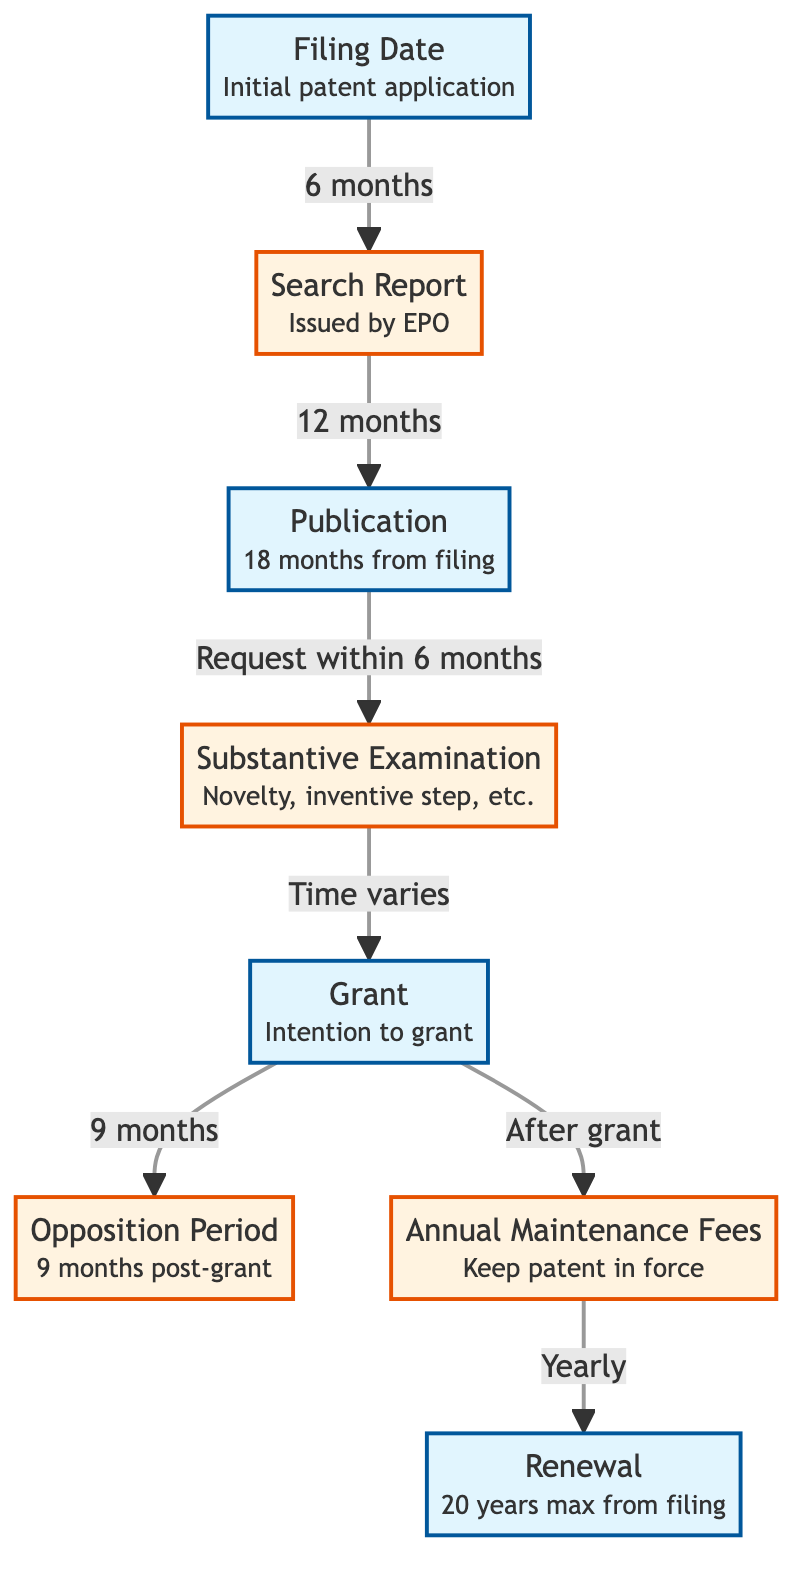What is the first milestone in the timeline? The diagram clearly indicates that the first milestone is the "Filing Date" of the initial patent application. This is the starting point from which all subsequent events are measured.
Answer: Filing Date How long after the filing date is the Search Report issued? Following the "Filing Date," the diagram states that the Search Report is issued after "6 months." This is directly indicated in the relationship between these two nodes.
Answer: 6 months What event occurs 18 months after the filing date? The diagram specifies that the "Publication" of the patent application occurs "18 months from filing." This timeline is clearly indicated between the Filing Date and Publication nodes.
Answer: Publication What is required within 6 months after publication to proceed to substantive examination? The arrow connecting the "Publication" and "Substantive Examination" nodes indicates that a "Request within 6 months" is necessary to initiate the substantive examination process. This is a critical next step in the timeline.
Answer: Request within 6 months How long is the opposition period after the grant? According to the diagram, the "Opposition Period" is specified as "9 months post-grant." This is indicated directly below the Grant milestone, showing the time frame allowed for opposition.
Answer: 9 months What is the maximum duration of maintenance for a patent from the filing date? The diagram indicates that the "Renewal" indicates "20 years max from filing," which specifies the total time for which the patent can be maintained and renewed following its filing.
Answer: 20 years What follows the grant in maintaining patent protection? The diagram shows that following the "Grant," the next step is the "Annual Maintenance Fees." This indicates the requirement for ongoing payments necessary to keep the patent in force.
Answer: Annual Maintenance Fees How does the substantive examination relate to the grant process? The relationship between the "Substantive Examination" and "Grant" nodes indicates that examination timing varies, thus implying there is no fixed duration for this step; it must be completed before the grant is issued.
Answer: Time varies What defines the annual maintenance requirements throughout the patent's life? The diagram outlines that "Annual Maintenance Fees" must be paid "Yearly," indicating that this is a recurring requirement throughout the life of the patent to keep it enforced.
Answer: Yearly What is the connection between the filing date and the issuance of the search report? The diagram establishes a clear directional relationship wherein the "Filing Date" leads to the "Search Report" after a duration of "6 months," marking a critical progression in the patent application process.
Answer: 6 months 